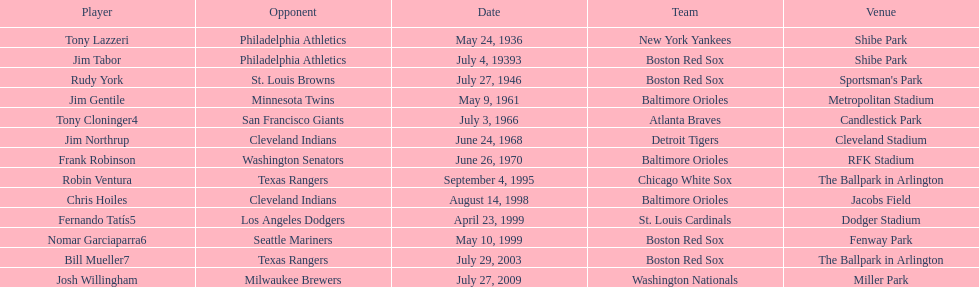Who were all the teams? New York Yankees, Boston Red Sox, Boston Red Sox, Baltimore Orioles, Atlanta Braves, Detroit Tigers, Baltimore Orioles, Chicago White Sox, Baltimore Orioles, St. Louis Cardinals, Boston Red Sox, Boston Red Sox, Washington Nationals. What about opponents? Philadelphia Athletics, Philadelphia Athletics, St. Louis Browns, Minnesota Twins, San Francisco Giants, Cleveland Indians, Washington Senators, Texas Rangers, Cleveland Indians, Los Angeles Dodgers, Seattle Mariners, Texas Rangers, Milwaukee Brewers. And when did they play? May 24, 1936, July 4, 19393, July 27, 1946, May 9, 1961, July 3, 1966, June 24, 1968, June 26, 1970, September 4, 1995, August 14, 1998, April 23, 1999, May 10, 1999, July 29, 2003, July 27, 2009. Which team played the red sox on july 27, 1946	? St. Louis Browns. 